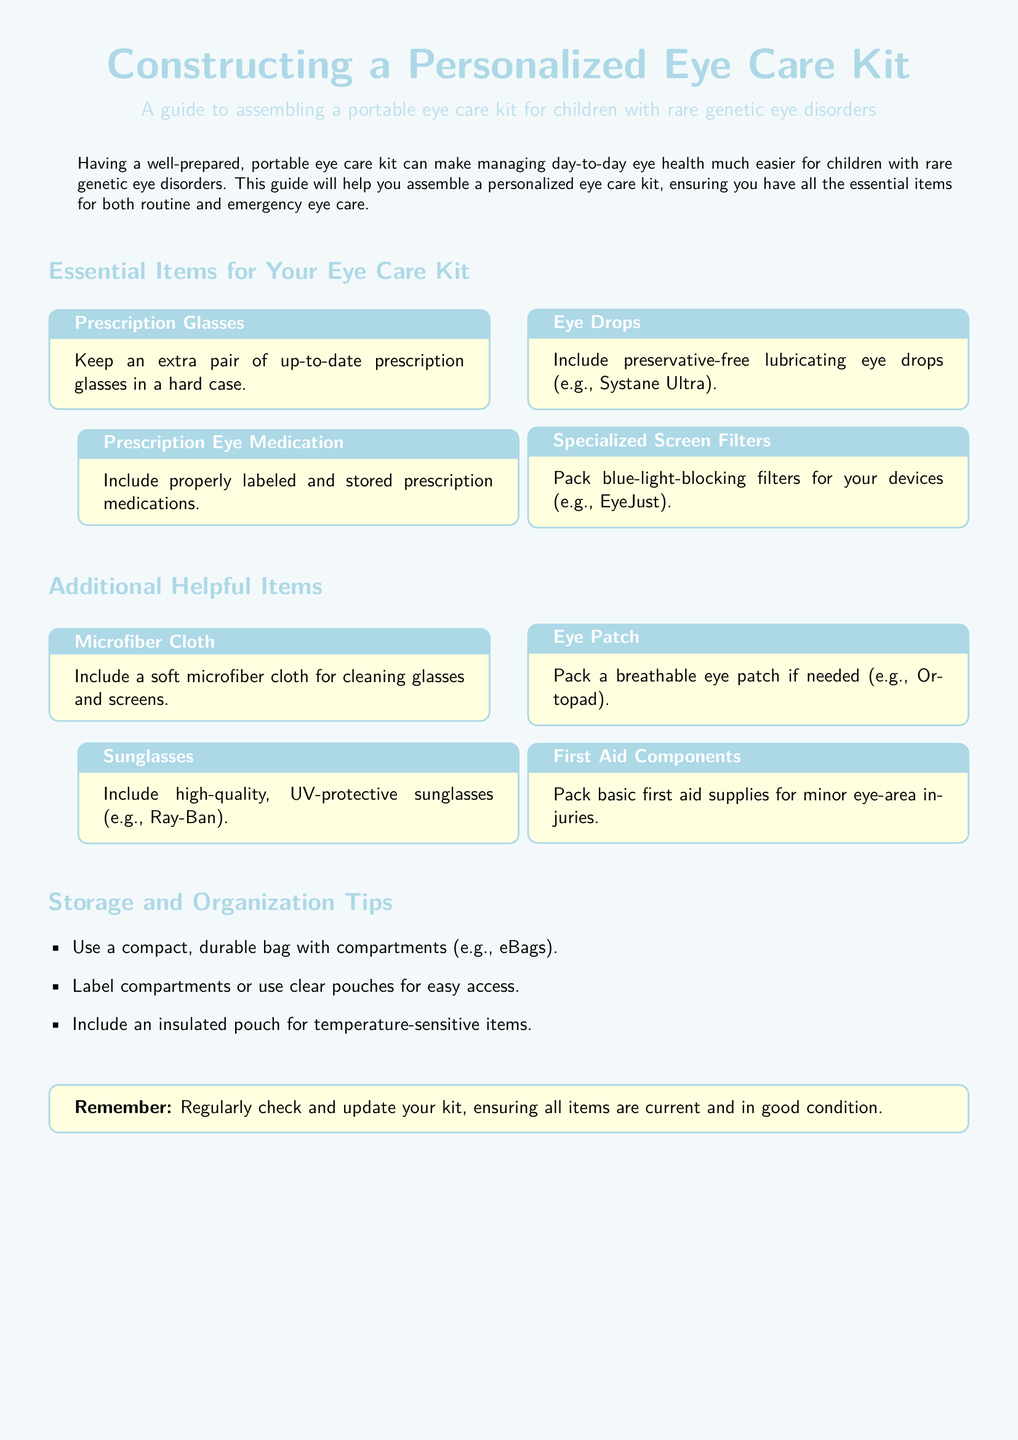What is the title of the guide? The title of the guide is mentioned in the header section of the document.
Answer: Constructing a Personalized Eye Care Kit What is one type of eye drop recommended? The document lists a specific type of eye drop that should be included in the kit.
Answer: Systane Ultra How should prescription glasses be stored? The document specifies how to keep extra prescription glasses organized.
Answer: In a hard case What item is suggested for cleaning glasses and screens? The guide includes an item specifically for cleaning purposes.
Answer: Microfiber Cloth What should be included for temperature-sensitive items? The document highlights a specific type of pouch for certain items.
Answer: Insulated pouch How many essential items are listed in the eye care kit? The document provides a total count of essential items in the eye care section.
Answer: Four What is the color of the page background? The document describes the background color used in its design.
Answer: Baby blue What type of sunglasses should be included? The document mentions a specific quality for sunglasses that are recommended.
Answer: UV-protective What should you regularly check in the eye care kit? The document has a reminder about maintaining certain aspects of the kit.
Answer: Items are current and in good condition 